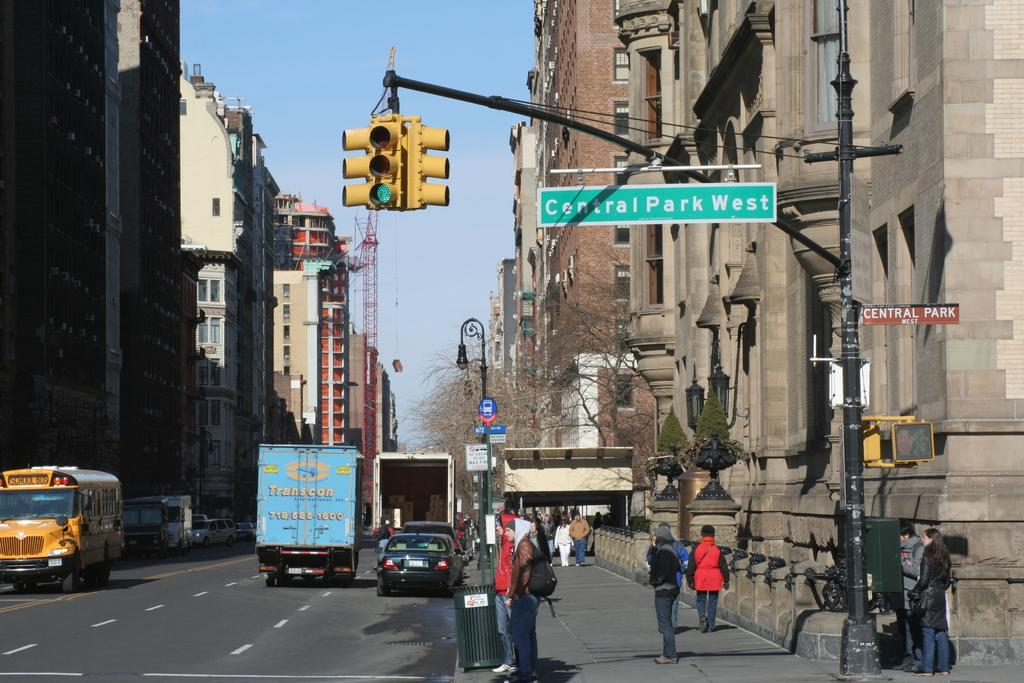<image>
Give a short and clear explanation of the subsequent image. A city street with people walking near a street sign that says Central Park West. 